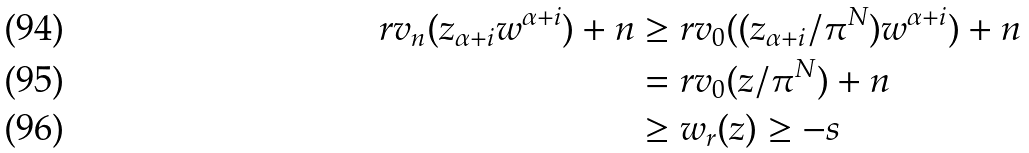<formula> <loc_0><loc_0><loc_500><loc_500>r v _ { n } ( z _ { \alpha + i } w ^ { \alpha + i } ) + n & \geq r v _ { 0 } ( ( z _ { \alpha + i } / \pi ^ { N } ) w ^ { \alpha + i } ) + n \\ & = r v _ { 0 } ( z / \pi ^ { N } ) + n \\ & \geq w _ { r } ( z ) \geq - s</formula> 